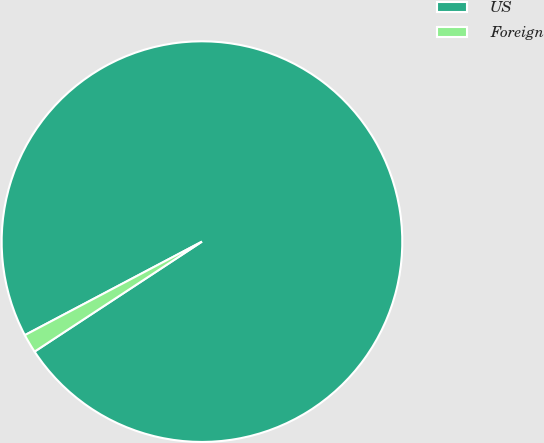Convert chart. <chart><loc_0><loc_0><loc_500><loc_500><pie_chart><fcel>US<fcel>Foreign<nl><fcel>98.48%<fcel>1.52%<nl></chart> 